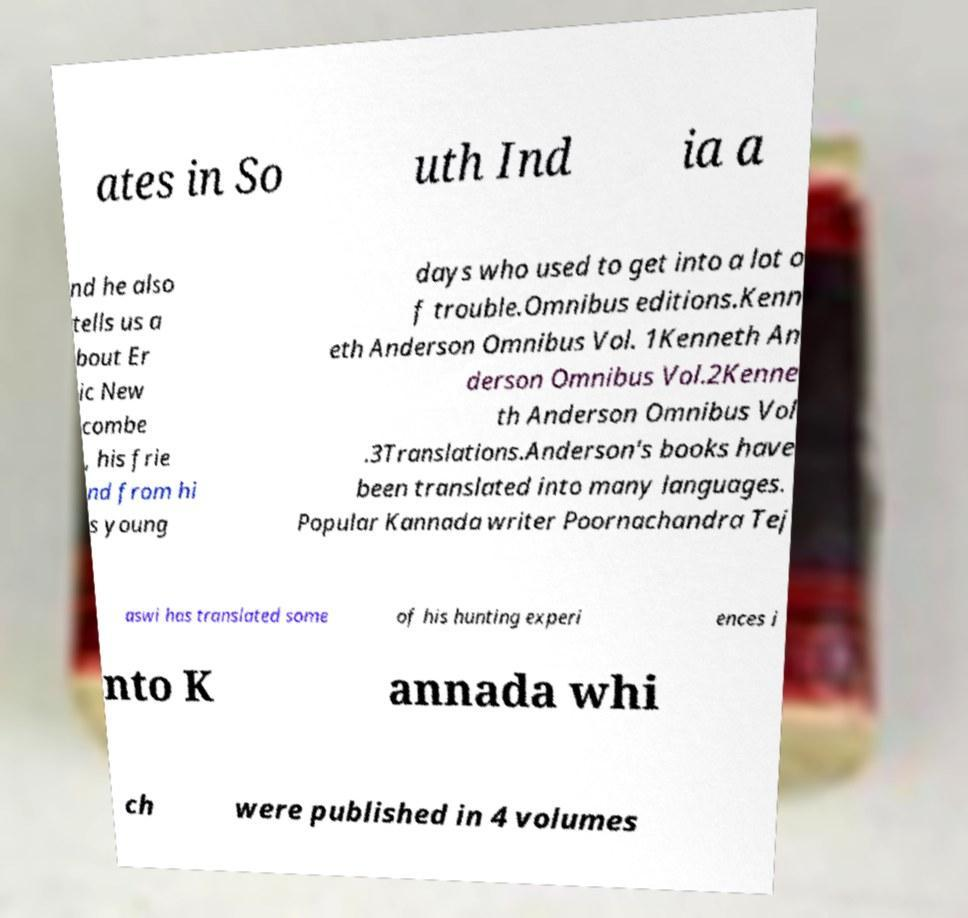Please identify and transcribe the text found in this image. ates in So uth Ind ia a nd he also tells us a bout Er ic New combe , his frie nd from hi s young days who used to get into a lot o f trouble.Omnibus editions.Kenn eth Anderson Omnibus Vol. 1Kenneth An derson Omnibus Vol.2Kenne th Anderson Omnibus Vol .3Translations.Anderson's books have been translated into many languages. Popular Kannada writer Poornachandra Tej aswi has translated some of his hunting experi ences i nto K annada whi ch were published in 4 volumes 